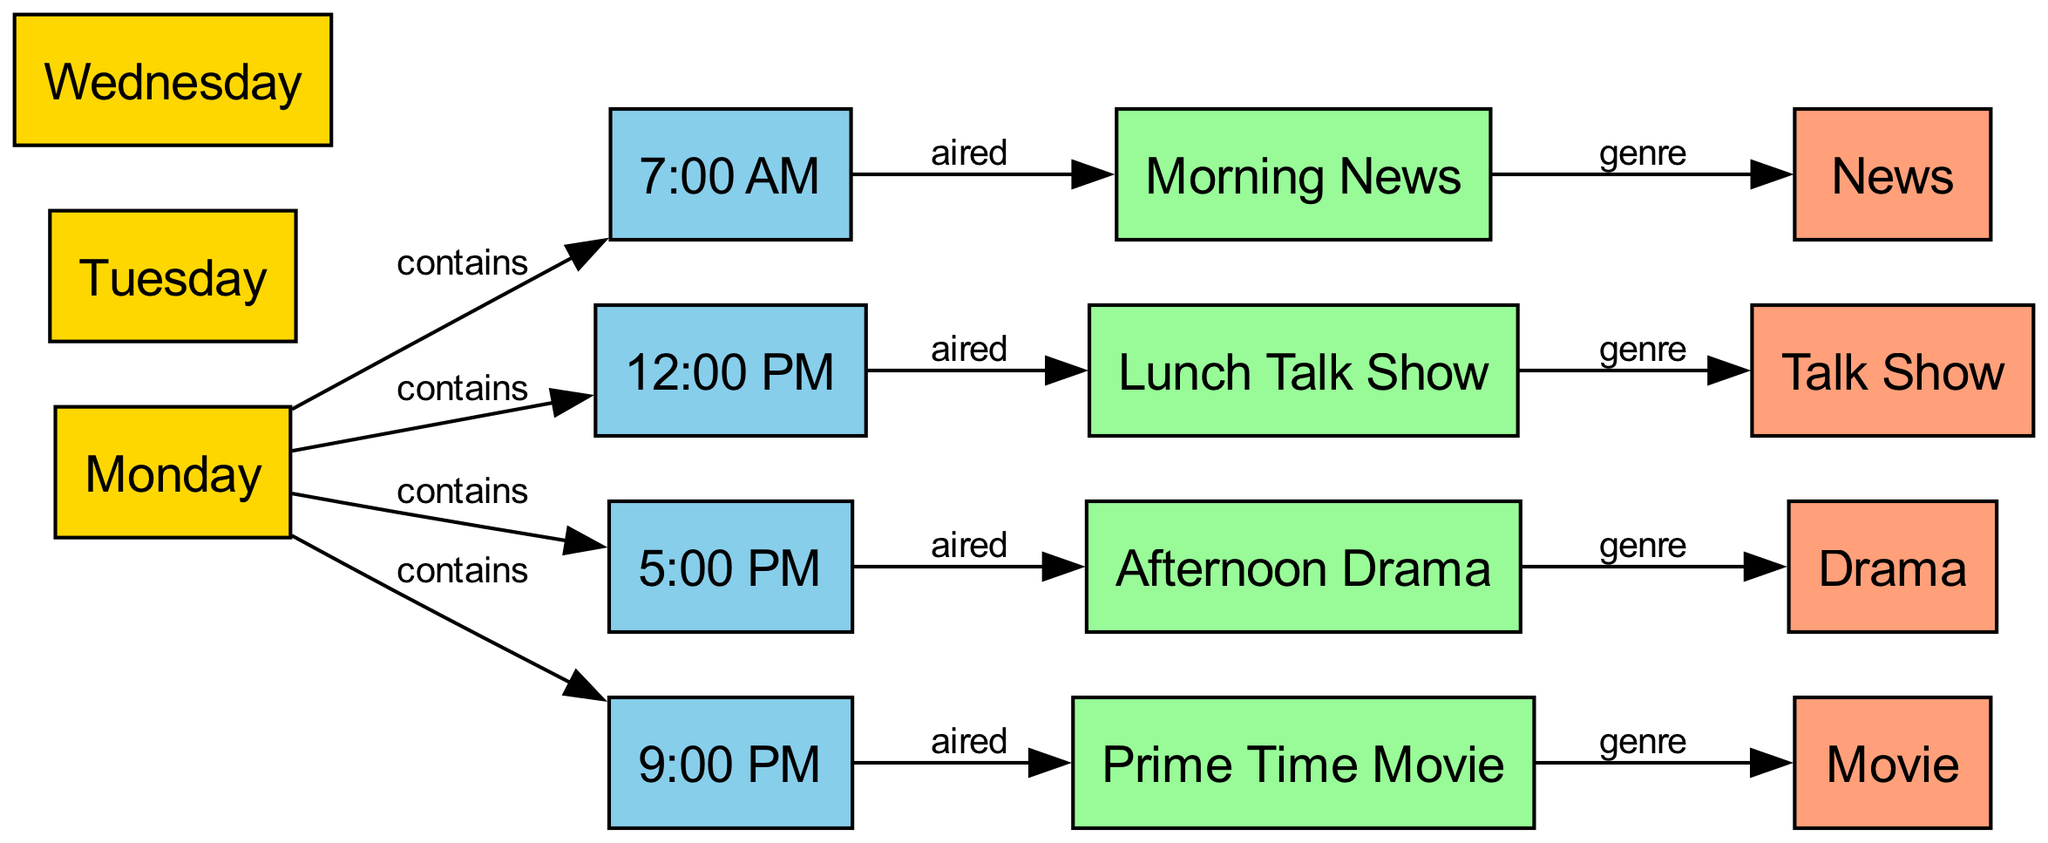what programs are aired at 7:00 AM? The diagram shows that the program aired at 7:00 AM is labeled "Morning News." This is checked by locating the node for 7:00 AM and identifying the subsequent node connected by the "aired" edge.
Answer: Morning News what genre is associated with the Afternoon Drama? The Afternoon Drama node is connected to the genre node labeled "Drama." This relationship is identified by tracing the edge from the Afternoon Drama to its genre.
Answer: Drama how many days are represented in the schedule? The diagram lists three days: Monday, Tuesday, and Wednesday. This is confirmed by counting the day nodes present in the diagram.
Answer: 3 what genre is assigned to the Lunch Talk Show? The Lunch Talk Show node leads to the genre node labeled "Talk Show." This is determined by the edge connecting these two nodes in the diagram.
Answer: Talk Show what time slot is dedicated to the Prime Time Movie? According to the diagram, the Prime Time Movie is scheduled for 9:00 PM, as indicated by the edge connecting this program to the corresponding time node.
Answer: 9:00 PM which program is aired at 12:00 PM? The diagram indicates that the program aired at 12:00 PM is labeled "Lunch Talk Show." This is derived by looking at the time node for 12:00 PM and following the edge to the aired program.
Answer: Lunch Talk Show which day contains the Afternoon Drama time slot? The Afternoon Drama is scheduled for 5:00 PM, which is connected to the day labeled "Monday." Hence, Monday contains the 5:00 PM time slot where the Afternoon Drama is aired.
Answer: Monday what is the total number of programs listed in the diagram? The diagram includes four distinct programs: Morning News, Lunch Talk Show, Afternoon Drama, and Prime Time Movie. This is counted by tallying the program nodes present in the diagram.
Answer: 4 what time slot includes the News genre? The genre labeled "News" corresponds to the program aired at 7:00 AM, which is the Morning News. This is identified by tracing the relationship from the program to its genre.
Answer: 7:00 AM 